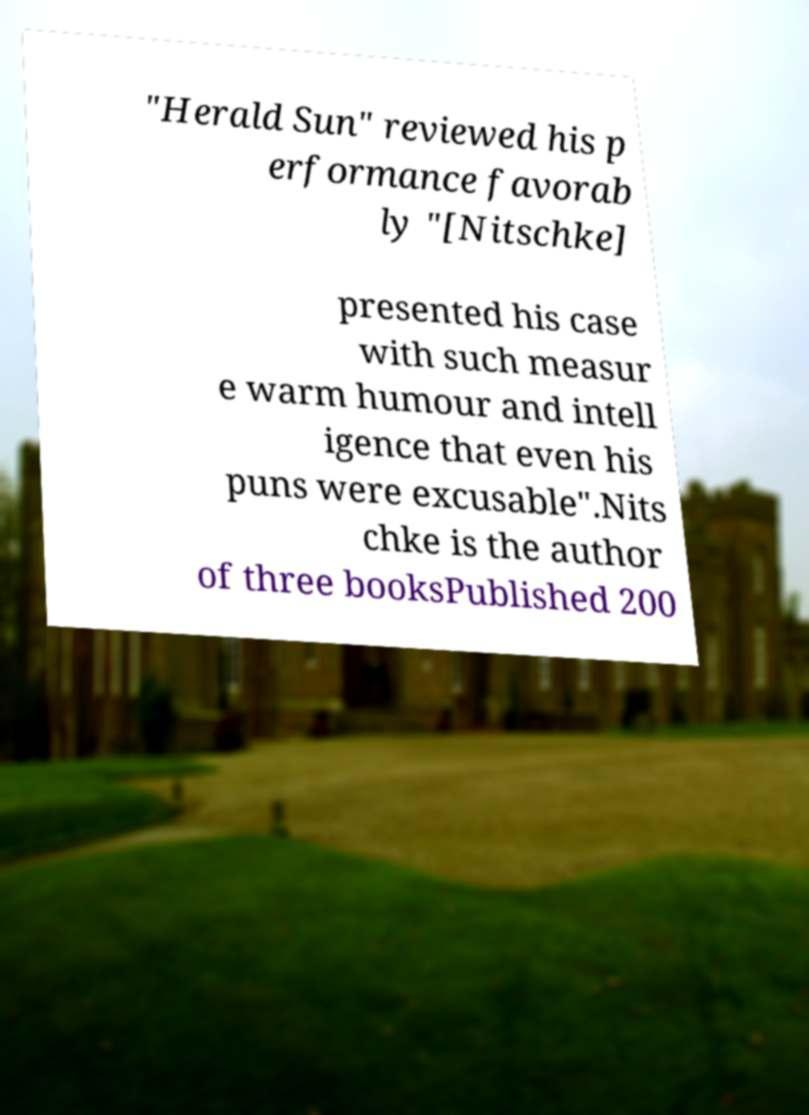What messages or text are displayed in this image? I need them in a readable, typed format. "Herald Sun" reviewed his p erformance favorab ly "[Nitschke] presented his case with such measur e warm humour and intell igence that even his puns were excusable".Nits chke is the author of three booksPublished 200 